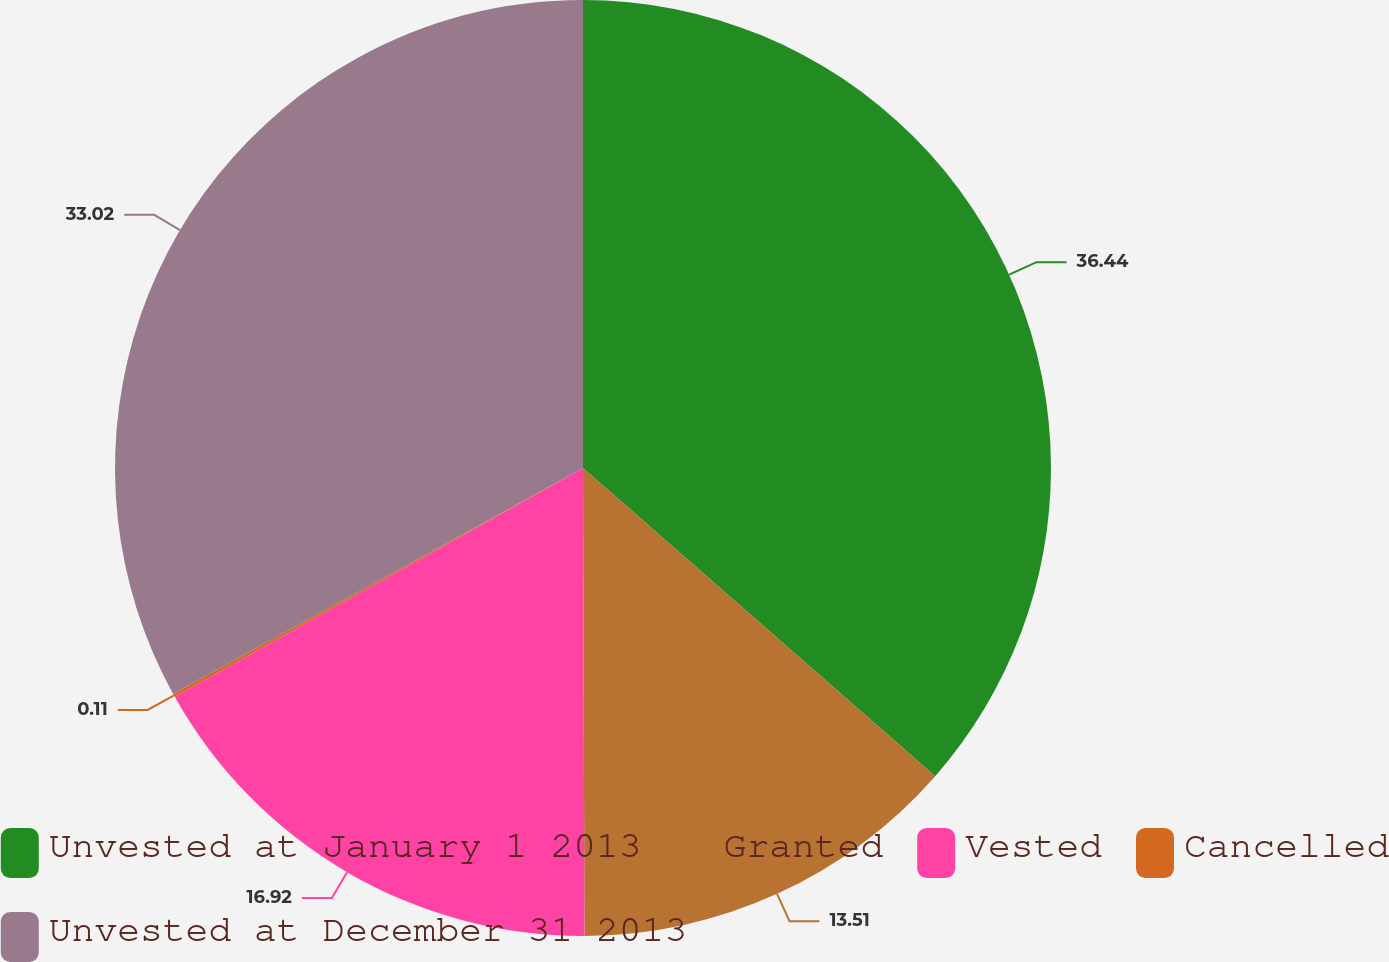Convert chart. <chart><loc_0><loc_0><loc_500><loc_500><pie_chart><fcel>Unvested at January 1 2013<fcel>Granted<fcel>Vested<fcel>Cancelled<fcel>Unvested at December 31 2013<nl><fcel>36.44%<fcel>13.51%<fcel>16.92%<fcel>0.11%<fcel>33.02%<nl></chart> 